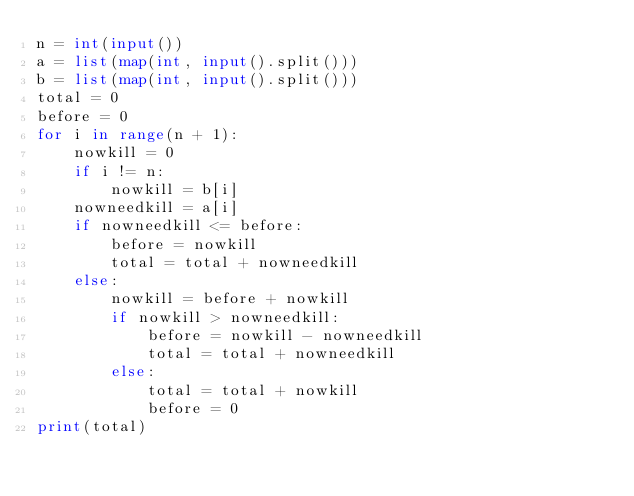Convert code to text. <code><loc_0><loc_0><loc_500><loc_500><_Python_>n = int(input())
a = list(map(int, input().split()))
b = list(map(int, input().split()))
total = 0
before = 0
for i in range(n + 1):
    nowkill = 0
    if i != n:
        nowkill = b[i]
    nowneedkill = a[i]
    if nowneedkill <= before:
        before = nowkill
        total = total + nowneedkill
    else:
        nowkill = before + nowkill
        if nowkill > nowneedkill:
            before = nowkill - nowneedkill
            total = total + nowneedkill
        else:
            total = total + nowkill
            before = 0
print(total)</code> 